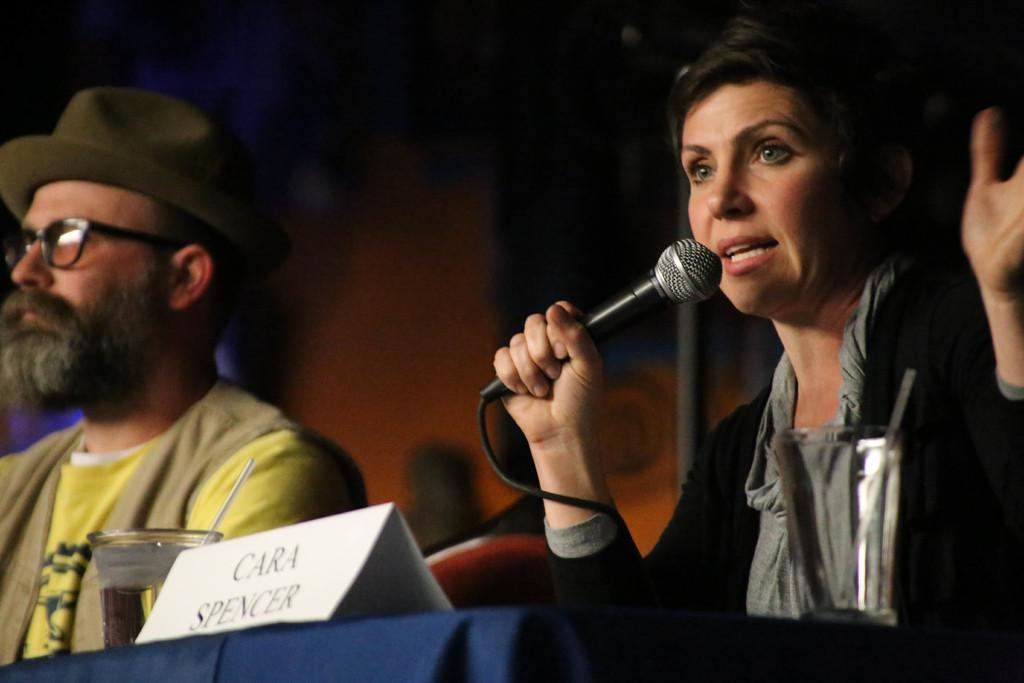In one or two sentences, can you explain what this image depicts? Background is dark and blur. We can see persons sitting on chairs in front of a table and on the table we can see glass with straws. This is a board. We can see this woman holding a mike in her hand and talking. 